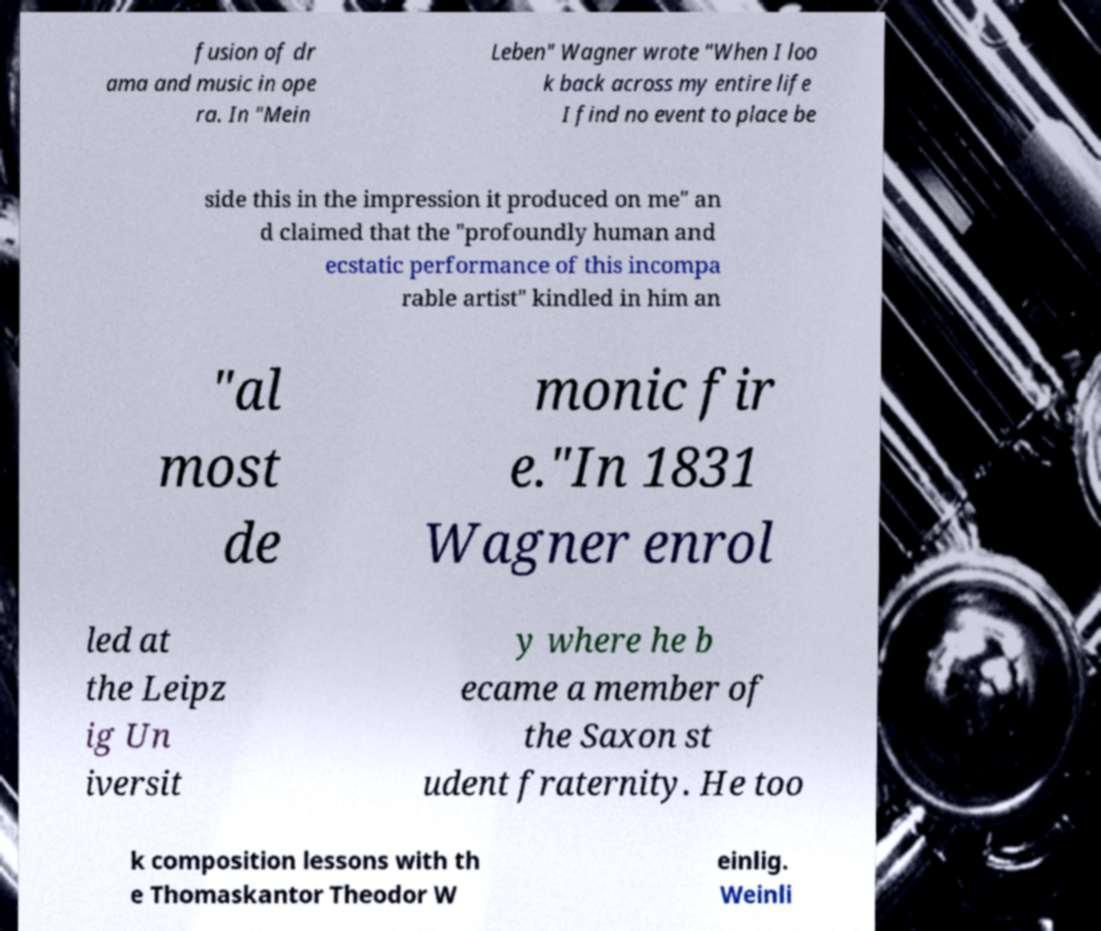Please read and relay the text visible in this image. What does it say? fusion of dr ama and music in ope ra. In "Mein Leben" Wagner wrote "When I loo k back across my entire life I find no event to place be side this in the impression it produced on me" an d claimed that the "profoundly human and ecstatic performance of this incompa rable artist" kindled in him an "al most de monic fir e."In 1831 Wagner enrol led at the Leipz ig Un iversit y where he b ecame a member of the Saxon st udent fraternity. He too k composition lessons with th e Thomaskantor Theodor W einlig. Weinli 